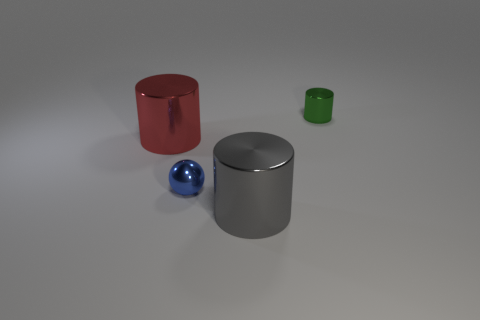Can you describe the sizes and colors of the objects in the image? Certainly! There are four objects in the image: a large red cylinder, a medium-sized silver cylinder, a small blue sphere, and a tiny green cylinder. 